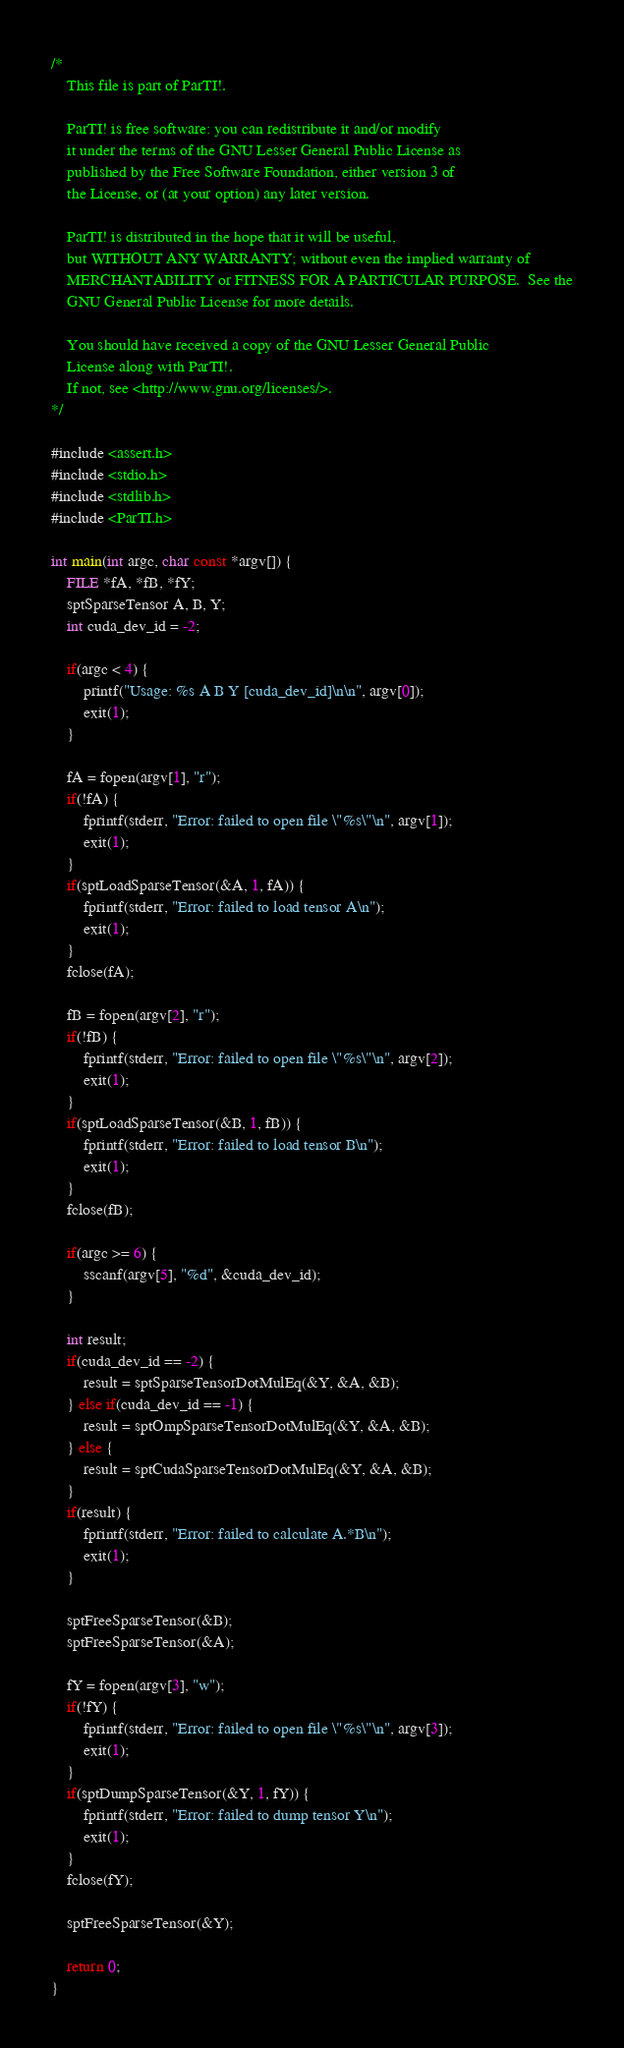Convert code to text. <code><loc_0><loc_0><loc_500><loc_500><_Cuda_>/*
    This file is part of ParTI!.

    ParTI! is free software: you can redistribute it and/or modify
    it under the terms of the GNU Lesser General Public License as
    published by the Free Software Foundation, either version 3 of
    the License, or (at your option) any later version.

    ParTI! is distributed in the hope that it will be useful,
    but WITHOUT ANY WARRANTY; without even the implied warranty of
    MERCHANTABILITY or FITNESS FOR A PARTICULAR PURPOSE.  See the
    GNU General Public License for more details.

    You should have received a copy of the GNU Lesser General Public
    License along with ParTI!.
    If not, see <http://www.gnu.org/licenses/>.
*/

#include <assert.h>
#include <stdio.h>
#include <stdlib.h>
#include <ParTI.h>

int main(int argc, char const *argv[]) {
    FILE *fA, *fB, *fY;
    sptSparseTensor A, B, Y;
    int cuda_dev_id = -2;

    if(argc < 4) {
        printf("Usage: %s A B Y [cuda_dev_id]\n\n", argv[0]);
        exit(1);
    }

    fA = fopen(argv[1], "r");
    if(!fA) {
        fprintf(stderr, "Error: failed to open file \"%s\"\n", argv[1]);
        exit(1);
    }
    if(sptLoadSparseTensor(&A, 1, fA)) {
        fprintf(stderr, "Error: failed to load tensor A\n");
        exit(1);
    }
    fclose(fA);

    fB = fopen(argv[2], "r");
    if(!fB) {
        fprintf(stderr, "Error: failed to open file \"%s\"\n", argv[2]);
        exit(1);
    }
    if(sptLoadSparseTensor(&B, 1, fB)) {
        fprintf(stderr, "Error: failed to load tensor B\n");
        exit(1);
    }
    fclose(fB);

    if(argc >= 6) {
        sscanf(argv[5], "%d", &cuda_dev_id);
    }

    int result;
    if(cuda_dev_id == -2) {
        result = sptSparseTensorDotMulEq(&Y, &A, &B);
    } else if(cuda_dev_id == -1) {
        result = sptOmpSparseTensorDotMulEq(&Y, &A, &B);
    } else {
        result = sptCudaSparseTensorDotMulEq(&Y, &A, &B);
    }
    if(result) {
        fprintf(stderr, "Error: failed to calculate A.*B\n");
        exit(1);
    }

    sptFreeSparseTensor(&B);
    sptFreeSparseTensor(&A);

    fY = fopen(argv[3], "w");
    if(!fY) {
        fprintf(stderr, "Error: failed to open file \"%s\"\n", argv[3]);
        exit(1);
    }
    if(sptDumpSparseTensor(&Y, 1, fY)) {
        fprintf(stderr, "Error: failed to dump tensor Y\n");
        exit(1);
    }
    fclose(fY);

    sptFreeSparseTensor(&Y);

    return 0;
}
</code> 